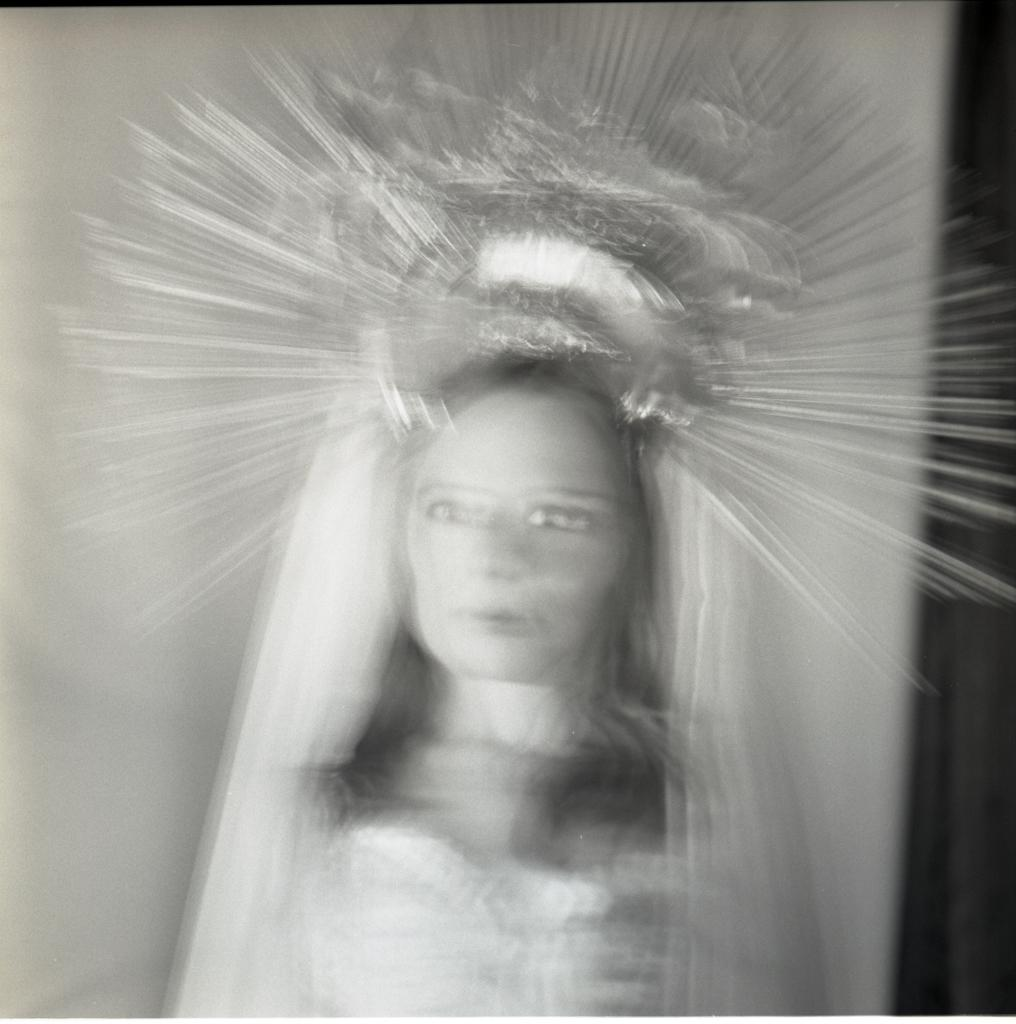Who is the main subject in the image? There is a woman in the image. What is the woman wearing on her head? The woman is wearing a crown. What is the color scheme of the image? The image is black and white. How would you describe the quality of the image? The image appears to be shaky. How many fairies are flying around the woman in the image? There are no fairies present in the image. What type of plate is the woman holding in the image? There is no plate visible in the image. 